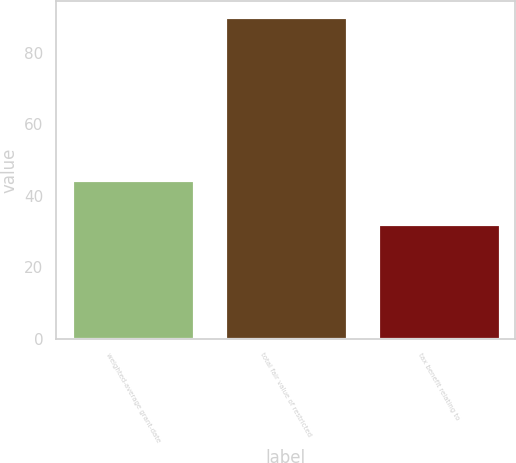<chart> <loc_0><loc_0><loc_500><loc_500><bar_chart><fcel>weighted-average grant-date<fcel>total fair value of restricted<fcel>tax benefit relating to<nl><fcel>44.38<fcel>90<fcel>32<nl></chart> 